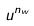<formula> <loc_0><loc_0><loc_500><loc_500>u ^ { n _ { w } }</formula> 